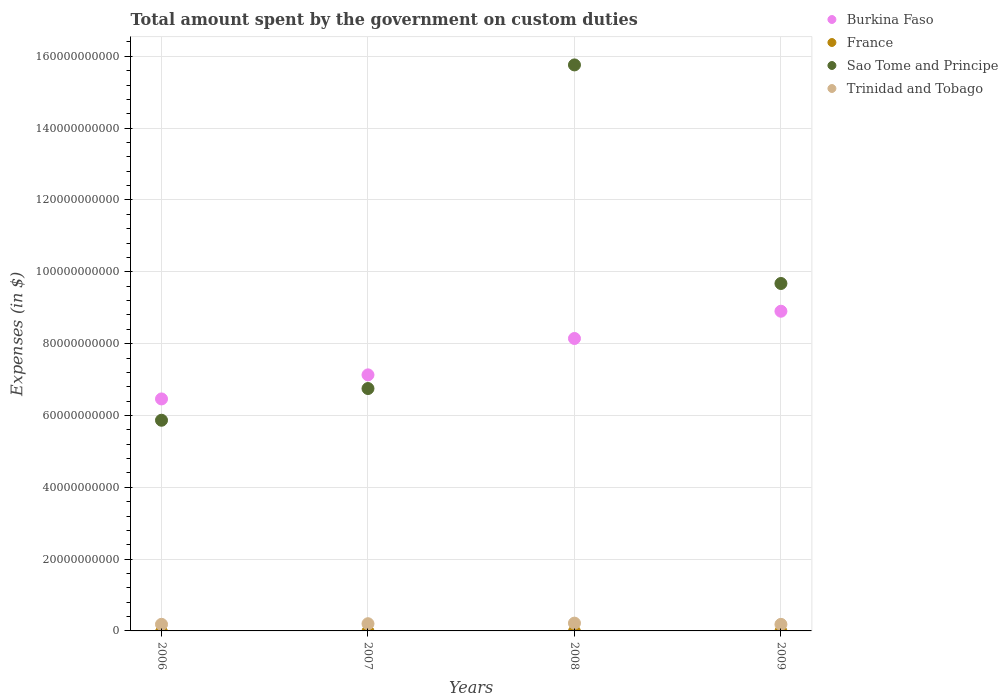Is the number of dotlines equal to the number of legend labels?
Provide a succinct answer. No. What is the amount spent on custom duties by the government in Sao Tome and Principe in 2008?
Your response must be concise. 1.58e+11. Across all years, what is the maximum amount spent on custom duties by the government in Burkina Faso?
Give a very brief answer. 8.90e+1. Across all years, what is the minimum amount spent on custom duties by the government in Sao Tome and Principe?
Provide a succinct answer. 5.87e+1. In which year was the amount spent on custom duties by the government in Sao Tome and Principe maximum?
Provide a succinct answer. 2008. What is the total amount spent on custom duties by the government in Burkina Faso in the graph?
Ensure brevity in your answer.  3.06e+11. What is the difference between the amount spent on custom duties by the government in Burkina Faso in 2008 and that in 2009?
Your response must be concise. -7.59e+09. What is the difference between the amount spent on custom duties by the government in Sao Tome and Principe in 2007 and the amount spent on custom duties by the government in Burkina Faso in 2009?
Keep it short and to the point. -2.15e+1. What is the average amount spent on custom duties by the government in Sao Tome and Principe per year?
Your answer should be very brief. 9.51e+1. In the year 2009, what is the difference between the amount spent on custom duties by the government in Sao Tome and Principe and amount spent on custom duties by the government in Burkina Faso?
Offer a very short reply. 7.72e+09. What is the ratio of the amount spent on custom duties by the government in Burkina Faso in 2007 to that in 2008?
Your response must be concise. 0.88. What is the difference between the highest and the second highest amount spent on custom duties by the government in Sao Tome and Principe?
Ensure brevity in your answer.  6.09e+1. What is the difference between the highest and the lowest amount spent on custom duties by the government in Sao Tome and Principe?
Your answer should be very brief. 9.89e+1. Is it the case that in every year, the sum of the amount spent on custom duties by the government in Trinidad and Tobago and amount spent on custom duties by the government in Sao Tome and Principe  is greater than the sum of amount spent on custom duties by the government in Burkina Faso and amount spent on custom duties by the government in France?
Ensure brevity in your answer.  No. Does the amount spent on custom duties by the government in Burkina Faso monotonically increase over the years?
Make the answer very short. Yes. Is the amount spent on custom duties by the government in Burkina Faso strictly less than the amount spent on custom duties by the government in France over the years?
Ensure brevity in your answer.  No. How many dotlines are there?
Keep it short and to the point. 3. Are the values on the major ticks of Y-axis written in scientific E-notation?
Keep it short and to the point. No. Does the graph contain grids?
Your answer should be compact. Yes. Where does the legend appear in the graph?
Offer a very short reply. Top right. How are the legend labels stacked?
Keep it short and to the point. Vertical. What is the title of the graph?
Ensure brevity in your answer.  Total amount spent by the government on custom duties. What is the label or title of the X-axis?
Keep it short and to the point. Years. What is the label or title of the Y-axis?
Provide a succinct answer. Expenses (in $). What is the Expenses (in $) in Burkina Faso in 2006?
Your answer should be very brief. 6.46e+1. What is the Expenses (in $) in France in 2006?
Keep it short and to the point. 0. What is the Expenses (in $) of Sao Tome and Principe in 2006?
Your answer should be compact. 5.87e+1. What is the Expenses (in $) in Trinidad and Tobago in 2006?
Ensure brevity in your answer.  1.84e+09. What is the Expenses (in $) in Burkina Faso in 2007?
Your answer should be compact. 7.13e+1. What is the Expenses (in $) in Sao Tome and Principe in 2007?
Offer a very short reply. 6.75e+1. What is the Expenses (in $) in Trinidad and Tobago in 2007?
Ensure brevity in your answer.  2.00e+09. What is the Expenses (in $) in Burkina Faso in 2008?
Your answer should be compact. 8.14e+1. What is the Expenses (in $) of France in 2008?
Ensure brevity in your answer.  0. What is the Expenses (in $) of Sao Tome and Principe in 2008?
Your response must be concise. 1.58e+11. What is the Expenses (in $) of Trinidad and Tobago in 2008?
Provide a succinct answer. 2.17e+09. What is the Expenses (in $) in Burkina Faso in 2009?
Offer a very short reply. 8.90e+1. What is the Expenses (in $) of Sao Tome and Principe in 2009?
Provide a short and direct response. 9.67e+1. What is the Expenses (in $) in Trinidad and Tobago in 2009?
Offer a very short reply. 1.83e+09. Across all years, what is the maximum Expenses (in $) of Burkina Faso?
Provide a short and direct response. 8.90e+1. Across all years, what is the maximum Expenses (in $) in Sao Tome and Principe?
Offer a terse response. 1.58e+11. Across all years, what is the maximum Expenses (in $) of Trinidad and Tobago?
Offer a terse response. 2.17e+09. Across all years, what is the minimum Expenses (in $) of Burkina Faso?
Your answer should be compact. 6.46e+1. Across all years, what is the minimum Expenses (in $) of Sao Tome and Principe?
Your answer should be compact. 5.87e+1. Across all years, what is the minimum Expenses (in $) of Trinidad and Tobago?
Offer a very short reply. 1.83e+09. What is the total Expenses (in $) of Burkina Faso in the graph?
Your response must be concise. 3.06e+11. What is the total Expenses (in $) of France in the graph?
Offer a very short reply. 0. What is the total Expenses (in $) of Sao Tome and Principe in the graph?
Keep it short and to the point. 3.81e+11. What is the total Expenses (in $) of Trinidad and Tobago in the graph?
Provide a short and direct response. 7.83e+09. What is the difference between the Expenses (in $) in Burkina Faso in 2006 and that in 2007?
Your answer should be very brief. -6.70e+09. What is the difference between the Expenses (in $) of Sao Tome and Principe in 2006 and that in 2007?
Your answer should be very brief. -8.83e+09. What is the difference between the Expenses (in $) of Trinidad and Tobago in 2006 and that in 2007?
Ensure brevity in your answer.  -1.68e+08. What is the difference between the Expenses (in $) of Burkina Faso in 2006 and that in 2008?
Your response must be concise. -1.68e+1. What is the difference between the Expenses (in $) of Sao Tome and Principe in 2006 and that in 2008?
Make the answer very short. -9.89e+1. What is the difference between the Expenses (in $) in Trinidad and Tobago in 2006 and that in 2008?
Offer a terse response. -3.32e+08. What is the difference between the Expenses (in $) of Burkina Faso in 2006 and that in 2009?
Your response must be concise. -2.44e+1. What is the difference between the Expenses (in $) in Sao Tome and Principe in 2006 and that in 2009?
Ensure brevity in your answer.  -3.81e+1. What is the difference between the Expenses (in $) in Trinidad and Tobago in 2006 and that in 2009?
Make the answer very short. 1.03e+07. What is the difference between the Expenses (in $) of Burkina Faso in 2007 and that in 2008?
Offer a very short reply. -1.01e+1. What is the difference between the Expenses (in $) of Sao Tome and Principe in 2007 and that in 2008?
Offer a terse response. -9.01e+1. What is the difference between the Expenses (in $) of Trinidad and Tobago in 2007 and that in 2008?
Offer a very short reply. -1.64e+08. What is the difference between the Expenses (in $) of Burkina Faso in 2007 and that in 2009?
Ensure brevity in your answer.  -1.77e+1. What is the difference between the Expenses (in $) of Sao Tome and Principe in 2007 and that in 2009?
Your response must be concise. -2.93e+1. What is the difference between the Expenses (in $) in Trinidad and Tobago in 2007 and that in 2009?
Offer a very short reply. 1.78e+08. What is the difference between the Expenses (in $) in Burkina Faso in 2008 and that in 2009?
Provide a short and direct response. -7.59e+09. What is the difference between the Expenses (in $) in Sao Tome and Principe in 2008 and that in 2009?
Give a very brief answer. 6.09e+1. What is the difference between the Expenses (in $) in Trinidad and Tobago in 2008 and that in 2009?
Keep it short and to the point. 3.42e+08. What is the difference between the Expenses (in $) in Burkina Faso in 2006 and the Expenses (in $) in Sao Tome and Principe in 2007?
Your answer should be compact. -2.89e+09. What is the difference between the Expenses (in $) in Burkina Faso in 2006 and the Expenses (in $) in Trinidad and Tobago in 2007?
Your answer should be compact. 6.26e+1. What is the difference between the Expenses (in $) in Sao Tome and Principe in 2006 and the Expenses (in $) in Trinidad and Tobago in 2007?
Provide a short and direct response. 5.67e+1. What is the difference between the Expenses (in $) of Burkina Faso in 2006 and the Expenses (in $) of Sao Tome and Principe in 2008?
Your response must be concise. -9.30e+1. What is the difference between the Expenses (in $) of Burkina Faso in 2006 and the Expenses (in $) of Trinidad and Tobago in 2008?
Offer a very short reply. 6.24e+1. What is the difference between the Expenses (in $) of Sao Tome and Principe in 2006 and the Expenses (in $) of Trinidad and Tobago in 2008?
Keep it short and to the point. 5.65e+1. What is the difference between the Expenses (in $) in Burkina Faso in 2006 and the Expenses (in $) in Sao Tome and Principe in 2009?
Keep it short and to the point. -3.21e+1. What is the difference between the Expenses (in $) of Burkina Faso in 2006 and the Expenses (in $) of Trinidad and Tobago in 2009?
Offer a terse response. 6.28e+1. What is the difference between the Expenses (in $) in Sao Tome and Principe in 2006 and the Expenses (in $) in Trinidad and Tobago in 2009?
Your response must be concise. 5.68e+1. What is the difference between the Expenses (in $) in Burkina Faso in 2007 and the Expenses (in $) in Sao Tome and Principe in 2008?
Your answer should be compact. -8.63e+1. What is the difference between the Expenses (in $) in Burkina Faso in 2007 and the Expenses (in $) in Trinidad and Tobago in 2008?
Your answer should be very brief. 6.91e+1. What is the difference between the Expenses (in $) in Sao Tome and Principe in 2007 and the Expenses (in $) in Trinidad and Tobago in 2008?
Offer a very short reply. 6.53e+1. What is the difference between the Expenses (in $) of Burkina Faso in 2007 and the Expenses (in $) of Sao Tome and Principe in 2009?
Ensure brevity in your answer.  -2.54e+1. What is the difference between the Expenses (in $) in Burkina Faso in 2007 and the Expenses (in $) in Trinidad and Tobago in 2009?
Ensure brevity in your answer.  6.95e+1. What is the difference between the Expenses (in $) in Sao Tome and Principe in 2007 and the Expenses (in $) in Trinidad and Tobago in 2009?
Keep it short and to the point. 6.57e+1. What is the difference between the Expenses (in $) of Burkina Faso in 2008 and the Expenses (in $) of Sao Tome and Principe in 2009?
Give a very brief answer. -1.53e+1. What is the difference between the Expenses (in $) of Burkina Faso in 2008 and the Expenses (in $) of Trinidad and Tobago in 2009?
Keep it short and to the point. 7.96e+1. What is the difference between the Expenses (in $) of Sao Tome and Principe in 2008 and the Expenses (in $) of Trinidad and Tobago in 2009?
Make the answer very short. 1.56e+11. What is the average Expenses (in $) in Burkina Faso per year?
Offer a very short reply. 7.66e+1. What is the average Expenses (in $) in Sao Tome and Principe per year?
Your response must be concise. 9.51e+1. What is the average Expenses (in $) of Trinidad and Tobago per year?
Offer a very short reply. 1.96e+09. In the year 2006, what is the difference between the Expenses (in $) of Burkina Faso and Expenses (in $) of Sao Tome and Principe?
Your response must be concise. 5.94e+09. In the year 2006, what is the difference between the Expenses (in $) of Burkina Faso and Expenses (in $) of Trinidad and Tobago?
Offer a terse response. 6.28e+1. In the year 2006, what is the difference between the Expenses (in $) of Sao Tome and Principe and Expenses (in $) of Trinidad and Tobago?
Provide a short and direct response. 5.68e+1. In the year 2007, what is the difference between the Expenses (in $) of Burkina Faso and Expenses (in $) of Sao Tome and Principe?
Ensure brevity in your answer.  3.81e+09. In the year 2007, what is the difference between the Expenses (in $) in Burkina Faso and Expenses (in $) in Trinidad and Tobago?
Your answer should be very brief. 6.93e+1. In the year 2007, what is the difference between the Expenses (in $) in Sao Tome and Principe and Expenses (in $) in Trinidad and Tobago?
Offer a very short reply. 6.55e+1. In the year 2008, what is the difference between the Expenses (in $) in Burkina Faso and Expenses (in $) in Sao Tome and Principe?
Your response must be concise. -7.62e+1. In the year 2008, what is the difference between the Expenses (in $) in Burkina Faso and Expenses (in $) in Trinidad and Tobago?
Offer a terse response. 7.93e+1. In the year 2008, what is the difference between the Expenses (in $) of Sao Tome and Principe and Expenses (in $) of Trinidad and Tobago?
Provide a short and direct response. 1.55e+11. In the year 2009, what is the difference between the Expenses (in $) in Burkina Faso and Expenses (in $) in Sao Tome and Principe?
Your answer should be compact. -7.72e+09. In the year 2009, what is the difference between the Expenses (in $) of Burkina Faso and Expenses (in $) of Trinidad and Tobago?
Your answer should be very brief. 8.72e+1. In the year 2009, what is the difference between the Expenses (in $) in Sao Tome and Principe and Expenses (in $) in Trinidad and Tobago?
Your answer should be compact. 9.49e+1. What is the ratio of the Expenses (in $) of Burkina Faso in 2006 to that in 2007?
Provide a short and direct response. 0.91. What is the ratio of the Expenses (in $) in Sao Tome and Principe in 2006 to that in 2007?
Give a very brief answer. 0.87. What is the ratio of the Expenses (in $) in Trinidad and Tobago in 2006 to that in 2007?
Keep it short and to the point. 0.92. What is the ratio of the Expenses (in $) in Burkina Faso in 2006 to that in 2008?
Provide a short and direct response. 0.79. What is the ratio of the Expenses (in $) in Sao Tome and Principe in 2006 to that in 2008?
Give a very brief answer. 0.37. What is the ratio of the Expenses (in $) in Trinidad and Tobago in 2006 to that in 2008?
Offer a very short reply. 0.85. What is the ratio of the Expenses (in $) of Burkina Faso in 2006 to that in 2009?
Your answer should be very brief. 0.73. What is the ratio of the Expenses (in $) in Sao Tome and Principe in 2006 to that in 2009?
Offer a terse response. 0.61. What is the ratio of the Expenses (in $) in Trinidad and Tobago in 2006 to that in 2009?
Your answer should be compact. 1.01. What is the ratio of the Expenses (in $) in Burkina Faso in 2007 to that in 2008?
Your answer should be compact. 0.88. What is the ratio of the Expenses (in $) in Sao Tome and Principe in 2007 to that in 2008?
Offer a very short reply. 0.43. What is the ratio of the Expenses (in $) in Trinidad and Tobago in 2007 to that in 2008?
Your response must be concise. 0.92. What is the ratio of the Expenses (in $) in Burkina Faso in 2007 to that in 2009?
Your response must be concise. 0.8. What is the ratio of the Expenses (in $) of Sao Tome and Principe in 2007 to that in 2009?
Make the answer very short. 0.7. What is the ratio of the Expenses (in $) in Trinidad and Tobago in 2007 to that in 2009?
Your answer should be compact. 1.1. What is the ratio of the Expenses (in $) in Burkina Faso in 2008 to that in 2009?
Your answer should be very brief. 0.91. What is the ratio of the Expenses (in $) in Sao Tome and Principe in 2008 to that in 2009?
Your answer should be compact. 1.63. What is the ratio of the Expenses (in $) of Trinidad and Tobago in 2008 to that in 2009?
Provide a succinct answer. 1.19. What is the difference between the highest and the second highest Expenses (in $) of Burkina Faso?
Give a very brief answer. 7.59e+09. What is the difference between the highest and the second highest Expenses (in $) of Sao Tome and Principe?
Offer a terse response. 6.09e+1. What is the difference between the highest and the second highest Expenses (in $) in Trinidad and Tobago?
Provide a succinct answer. 1.64e+08. What is the difference between the highest and the lowest Expenses (in $) of Burkina Faso?
Keep it short and to the point. 2.44e+1. What is the difference between the highest and the lowest Expenses (in $) in Sao Tome and Principe?
Provide a short and direct response. 9.89e+1. What is the difference between the highest and the lowest Expenses (in $) of Trinidad and Tobago?
Your answer should be very brief. 3.42e+08. 